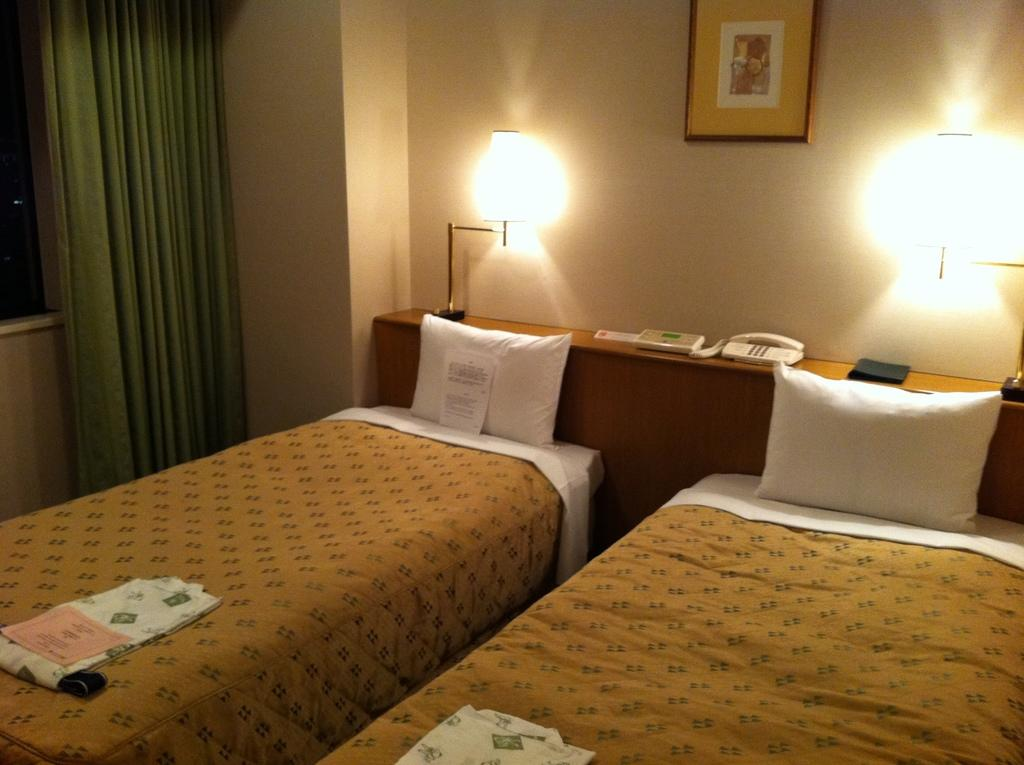What type of space is depicted in the image? The image is of a room. What furniture is present in the room? There are beds with pillows in the room. What can be seen near the window in the room? There is a curtain near the window in the room. What electronic device is on the table in the room? There is a telephone on a table in the room. What type of lighting is on the table in the room? There is a lantern lamp on the table in the room. What decorative item is on the wall in the room? There is a picture on the wall in the room. What type of attraction is being held in the room in the image? There is no indication of an attraction being held in the room in the image. The image simply shows a room with various objects and furniture. 